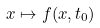<formula> <loc_0><loc_0><loc_500><loc_500>x \mapsto f ( x , t _ { 0 } )</formula> 